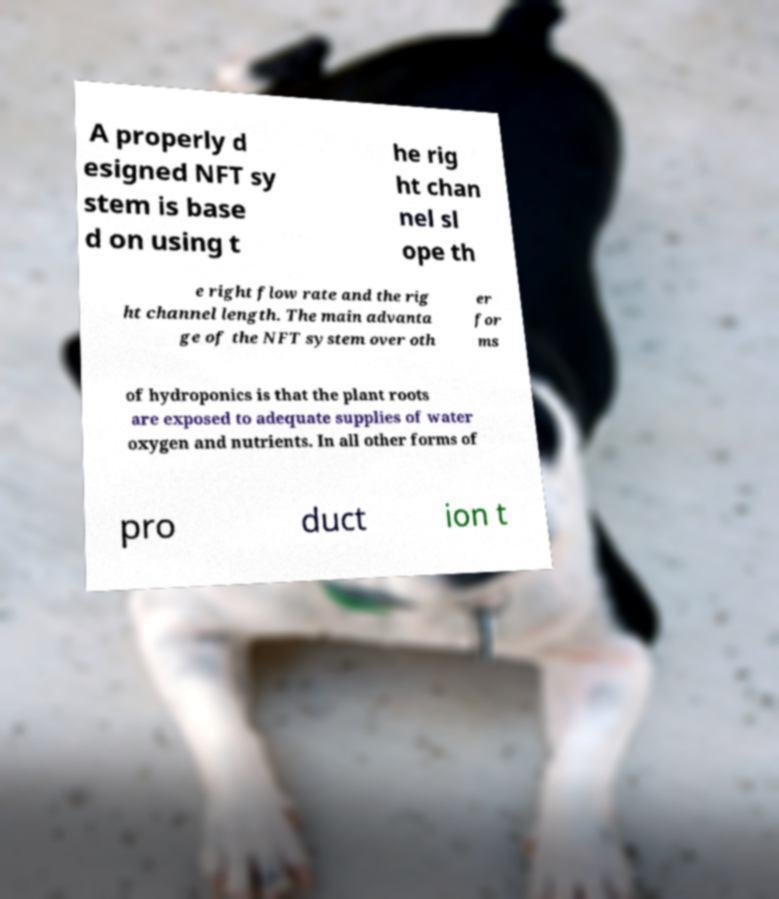Can you accurately transcribe the text from the provided image for me? A properly d esigned NFT sy stem is base d on using t he rig ht chan nel sl ope th e right flow rate and the rig ht channel length. The main advanta ge of the NFT system over oth er for ms of hydroponics is that the plant roots are exposed to adequate supplies of water oxygen and nutrients. In all other forms of pro duct ion t 